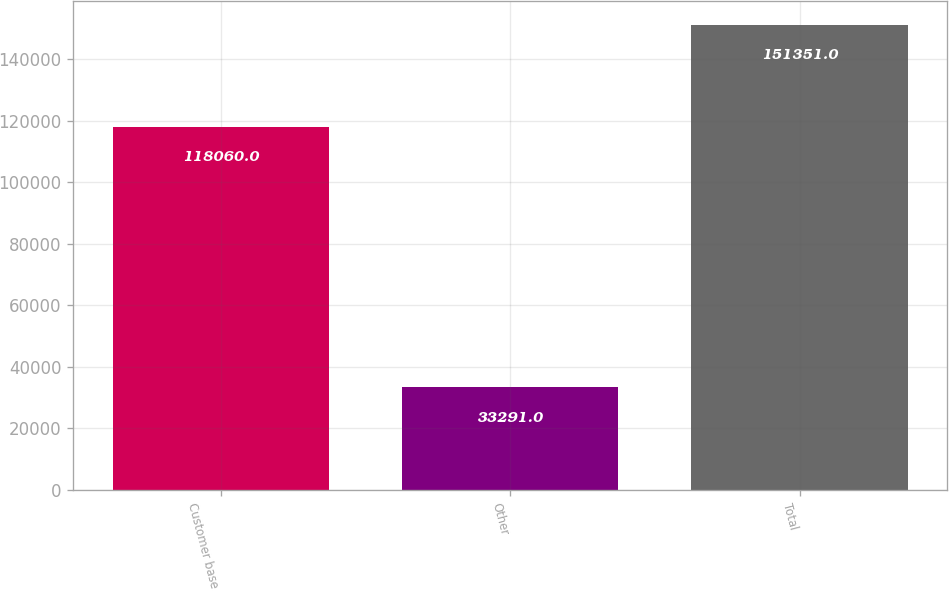<chart> <loc_0><loc_0><loc_500><loc_500><bar_chart><fcel>Customer base<fcel>Other<fcel>Total<nl><fcel>118060<fcel>33291<fcel>151351<nl></chart> 